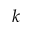<formula> <loc_0><loc_0><loc_500><loc_500>k</formula> 